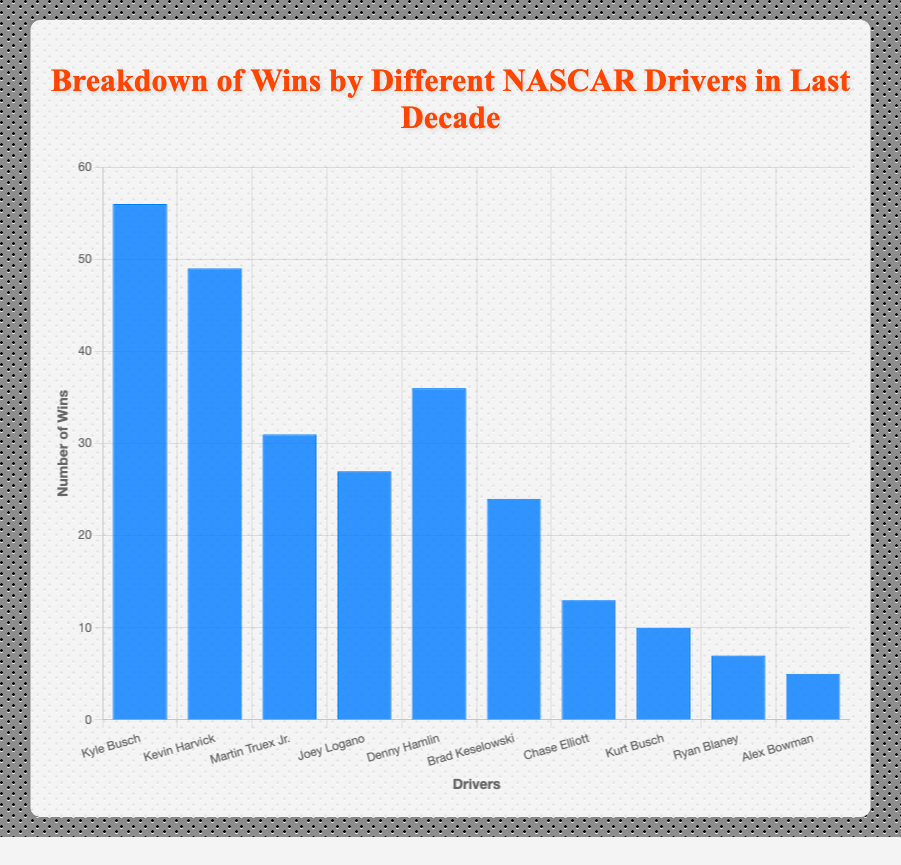What are the total wins of Kyle Busch and Denny Hamlin? Kyle Busch has 56 wins and Denny Hamlin has 36 wins. Adding them together: 56 + 36 = 92
Answer: 92 Which driver has the least number of wins? From the bar chart, Alex Bowman has the shortest bar, indicating he has the least number of wins, which is 5
Answer: Alex Bowman How many more wins does Kevin Harvick have compared to Brad Keselowski? Kevin Harvick has 49 wins and Brad Keselowski has 24 wins. The difference is 49 - 24 = 25
Answer: 25 Who has more wins, Joey Logano or Martin Truex Jr.? Martin Truex Jr. has 31 wins, while Joey Logano has 27 wins. Therefore, Martin Truex Jr. has more wins
Answer: Martin Truex Jr What is the total number of wins for all drivers combined? Sum all the wins: 56 (Kyle Busch) + 49 (Kevin Harvick) + 31 (Martin Truex Jr.) + 27 (Joey Logano) + 36 (Denny Hamlin) + 24 (Brad Keselowski) + 13 (Chase Elliott) + 10 (Kurt Busch) + 7 (Ryan Blaney) + 5 (Alex Bowman) = 258
Answer: 258 Is Kevin Harvick's total wins more than twice the wins of Kurt Busch? Kevin Harvick has 49 wins and Kurt Busch has 10 wins. Doubling Kurt Busch's wins gives 10 * 2 = 20, and 49 > 20
Answer: Yes What is the average number of wins for the listed drivers? The total number of wins is 258 and there are 10 drivers. The average is 258 / 10 = 25.8
Answer: 25.8 Which driver has the second highest number of wins? Kyle Busch has the highest number of wins at 56. The next driver is Kevin Harvick with 49 wins
Answer: Kevin Harvick How many drivers have won more than 30 races? The drivers who have won more than 30 races are Kyle Busch (56), Kevin Harvick (49), Denny Hamlin (36), and Martin Truex Jr. (31). That's 4 drivers
Answer: 4 